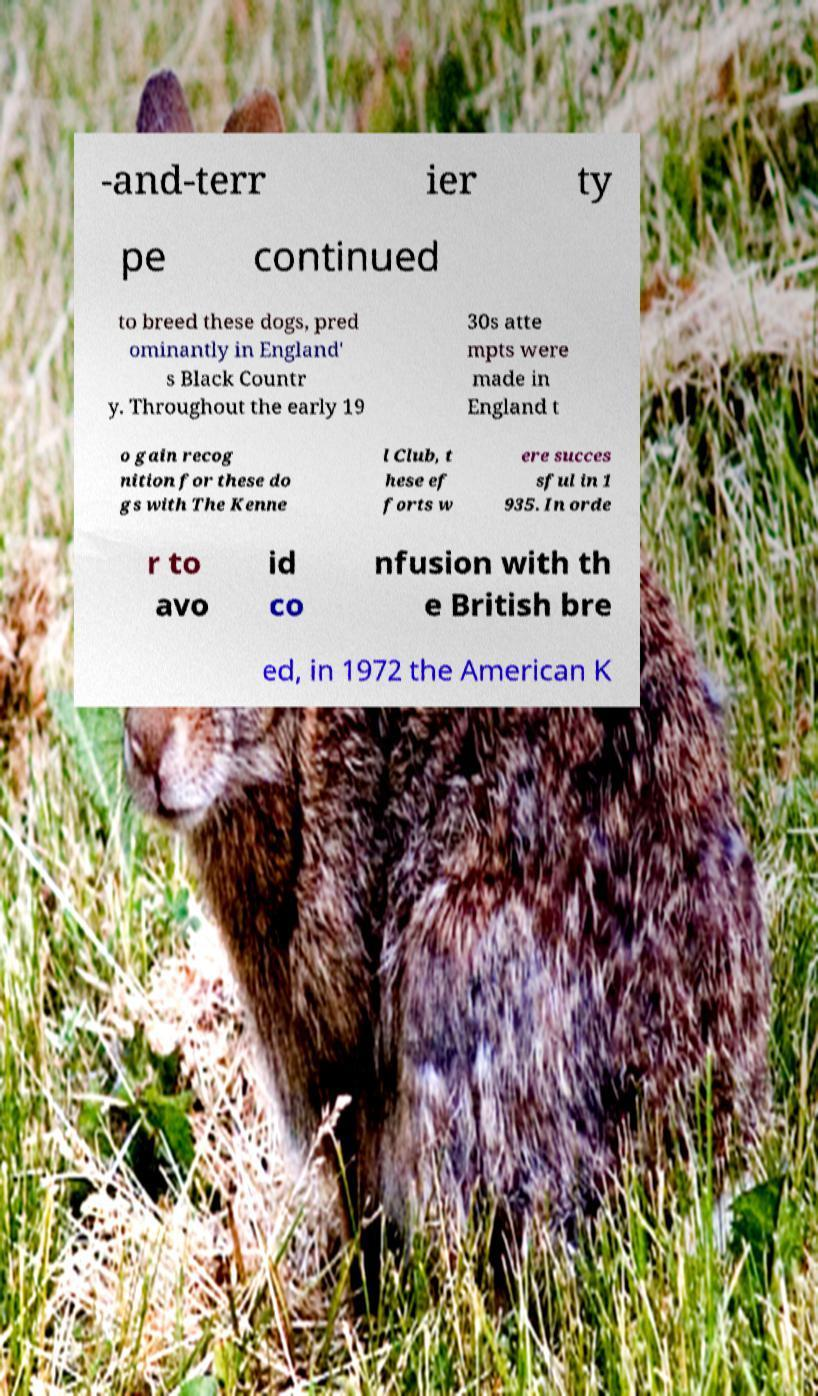Could you extract and type out the text from this image? -and-terr ier ty pe continued to breed these dogs, pred ominantly in England' s Black Countr y. Throughout the early 19 30s atte mpts were made in England t o gain recog nition for these do gs with The Kenne l Club, t hese ef forts w ere succes sful in 1 935. In orde r to avo id co nfusion with th e British bre ed, in 1972 the American K 